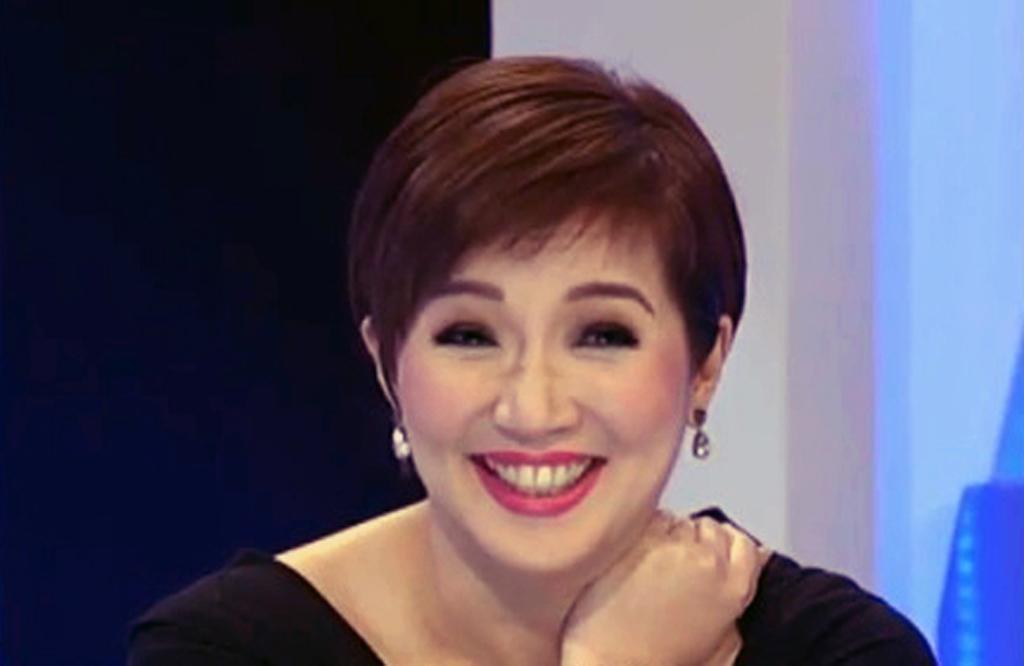Describe this image in one or two sentences. In the center of the image we can see a lady smiling. She is wearing a black dress. In the background there is a wall and a curtain. 